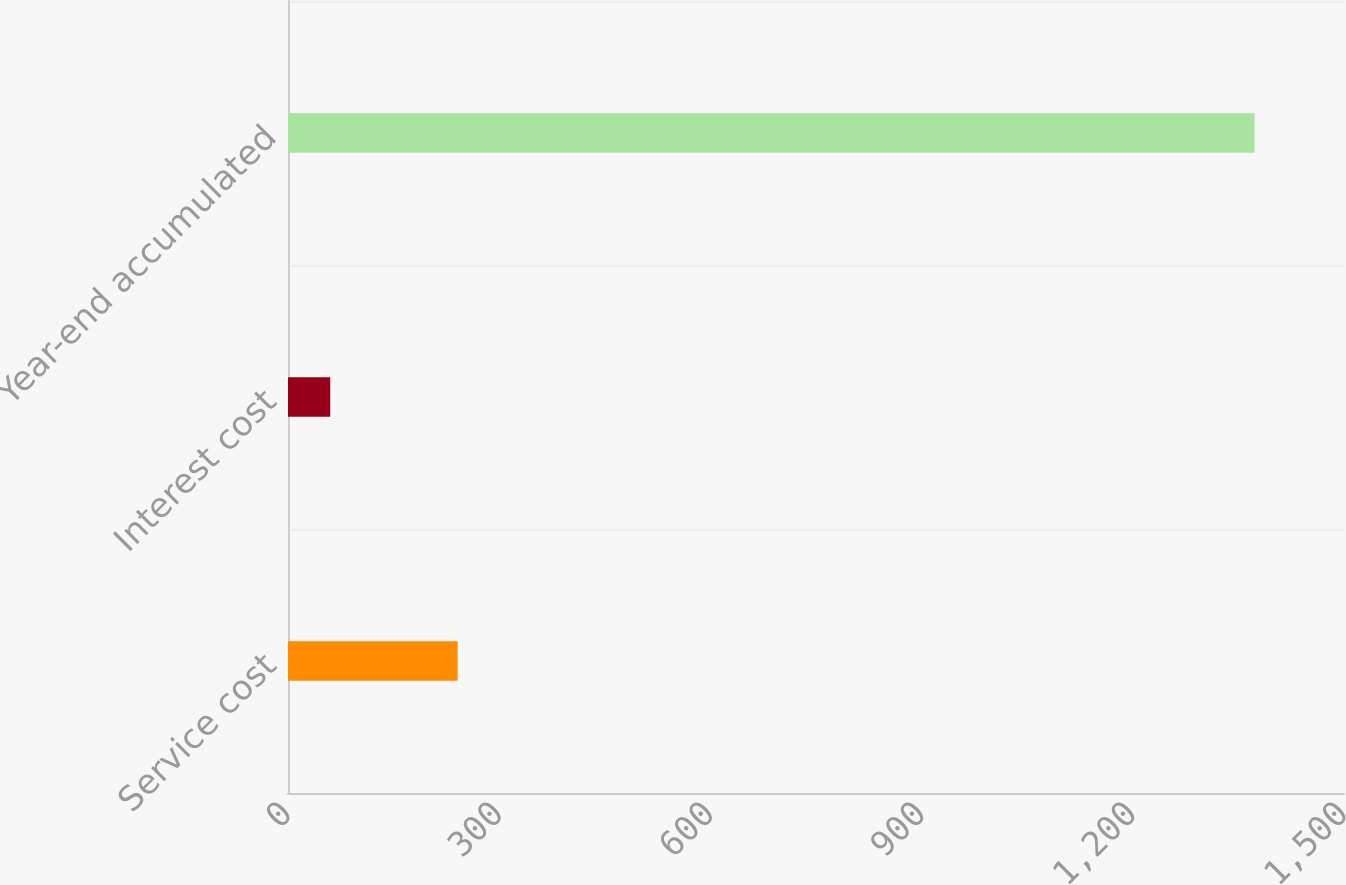Convert chart. <chart><loc_0><loc_0><loc_500><loc_500><bar_chart><fcel>Service cost<fcel>Interest cost<fcel>Year-end accumulated<nl><fcel>241<fcel>60<fcel>1373<nl></chart> 